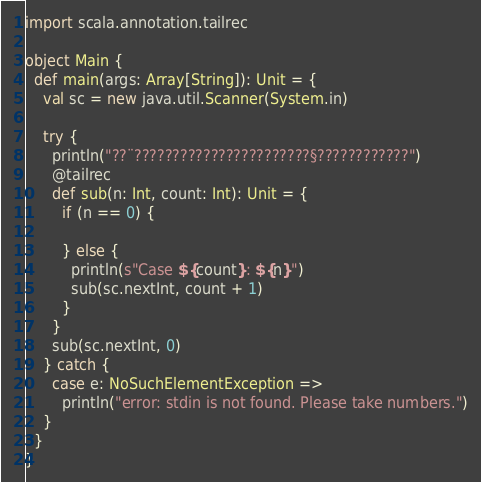Convert code to text. <code><loc_0><loc_0><loc_500><loc_500><_Scala_>import scala.annotation.tailrec

object Main {
  def main(args: Array[String]): Unit = {
    val sc = new java.util.Scanner(System.in)

    try {
      println("??¨???????????????????????§????????????")
      @tailrec
      def sub(n: Int, count: Int): Unit = {
        if (n == 0) {

        } else {
          println(s"Case ${count}: ${n}")
          sub(sc.nextInt, count + 1)
        }
      }
      sub(sc.nextInt, 0)
    } catch {
      case e: NoSuchElementException =>
        println("error: stdin is not found. Please take numbers.")
    }
  }
}</code> 